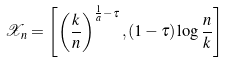<formula> <loc_0><loc_0><loc_500><loc_500>\mathcal { X } _ { n } = \left [ \left ( \frac { k } { n } \right ) ^ { \frac { 1 } { a } - \tau } , ( 1 - \tau ) \log \frac { n } { k } \right ]</formula> 